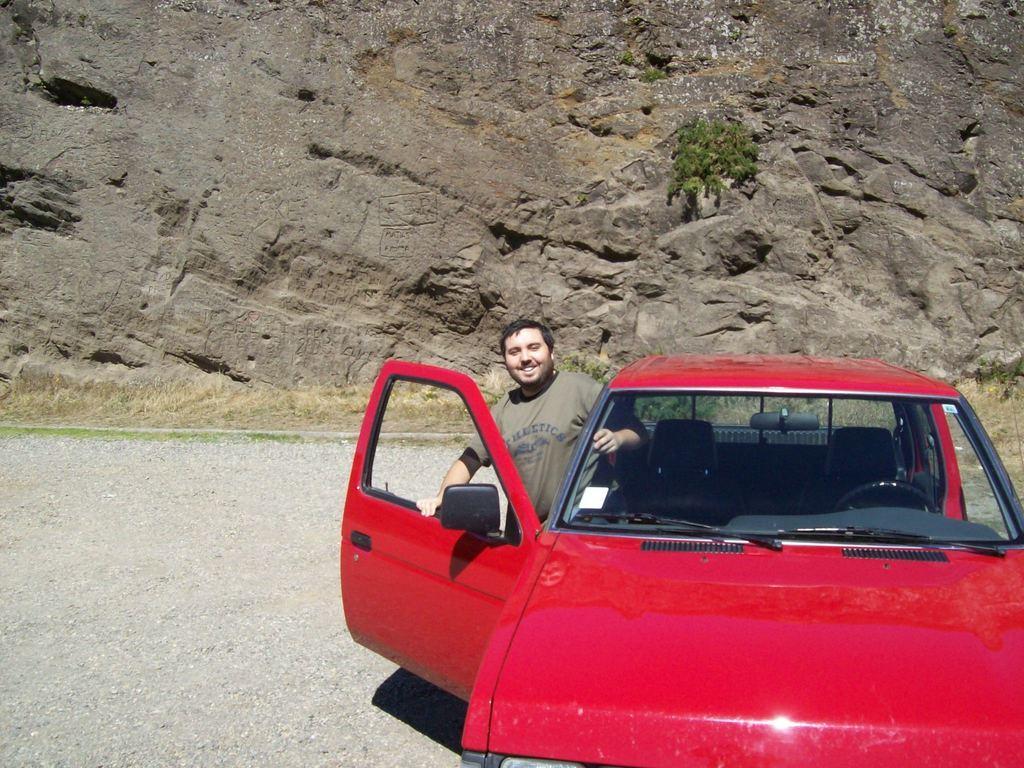How would you summarize this image in a sentence or two? In this image, we can see a person beside the car which is in front of the hill. 